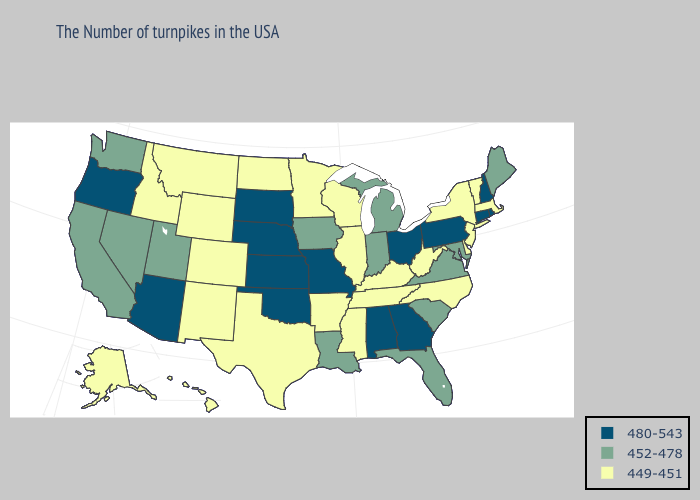What is the value of Iowa?
Quick response, please. 452-478. Name the states that have a value in the range 480-543?
Quick response, please. Rhode Island, New Hampshire, Connecticut, Pennsylvania, Ohio, Georgia, Alabama, Missouri, Kansas, Nebraska, Oklahoma, South Dakota, Arizona, Oregon. Name the states that have a value in the range 452-478?
Quick response, please. Maine, Maryland, Virginia, South Carolina, Florida, Michigan, Indiana, Louisiana, Iowa, Utah, Nevada, California, Washington. What is the lowest value in the South?
Keep it brief. 449-451. Which states have the highest value in the USA?
Short answer required. Rhode Island, New Hampshire, Connecticut, Pennsylvania, Ohio, Georgia, Alabama, Missouri, Kansas, Nebraska, Oklahoma, South Dakota, Arizona, Oregon. Name the states that have a value in the range 449-451?
Answer briefly. Massachusetts, Vermont, New York, New Jersey, Delaware, North Carolina, West Virginia, Kentucky, Tennessee, Wisconsin, Illinois, Mississippi, Arkansas, Minnesota, Texas, North Dakota, Wyoming, Colorado, New Mexico, Montana, Idaho, Alaska, Hawaii. Does Wisconsin have the lowest value in the USA?
Keep it brief. Yes. What is the value of Pennsylvania?
Short answer required. 480-543. Name the states that have a value in the range 449-451?
Write a very short answer. Massachusetts, Vermont, New York, New Jersey, Delaware, North Carolina, West Virginia, Kentucky, Tennessee, Wisconsin, Illinois, Mississippi, Arkansas, Minnesota, Texas, North Dakota, Wyoming, Colorado, New Mexico, Montana, Idaho, Alaska, Hawaii. Name the states that have a value in the range 480-543?
Quick response, please. Rhode Island, New Hampshire, Connecticut, Pennsylvania, Ohio, Georgia, Alabama, Missouri, Kansas, Nebraska, Oklahoma, South Dakota, Arizona, Oregon. What is the lowest value in the Northeast?
Write a very short answer. 449-451. What is the value of Missouri?
Give a very brief answer. 480-543. Does Oregon have the highest value in the USA?
Quick response, please. Yes. What is the lowest value in states that border Vermont?
Keep it brief. 449-451. 